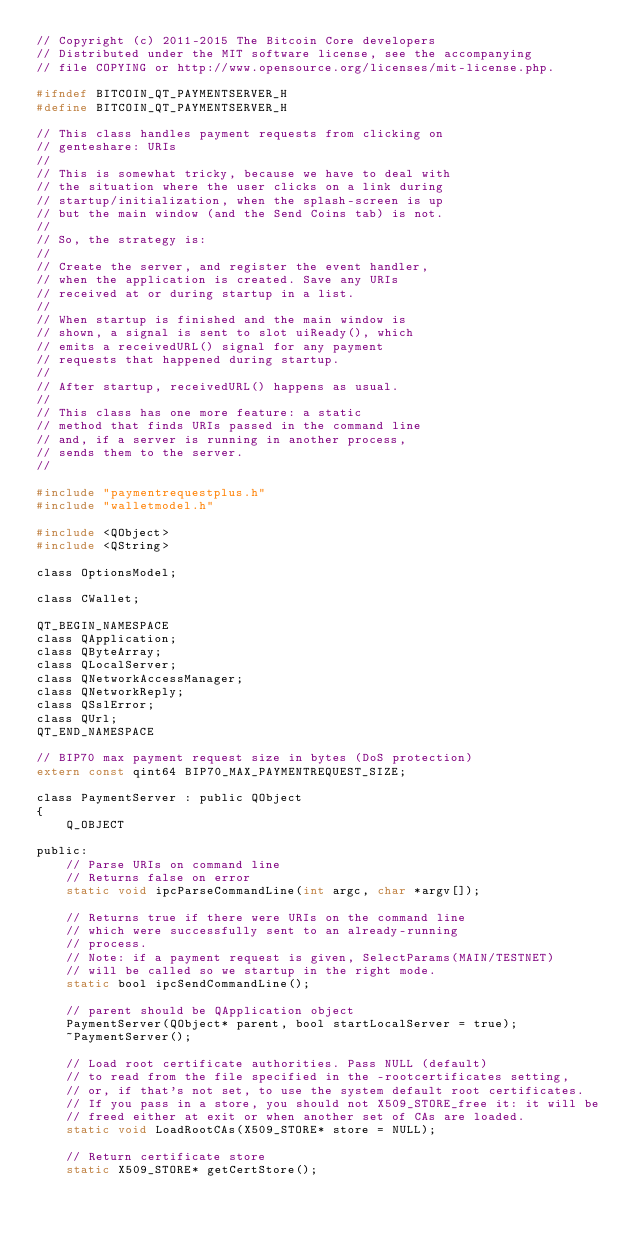Convert code to text. <code><loc_0><loc_0><loc_500><loc_500><_C_>// Copyright (c) 2011-2015 The Bitcoin Core developers
// Distributed under the MIT software license, see the accompanying
// file COPYING or http://www.opensource.org/licenses/mit-license.php.

#ifndef BITCOIN_QT_PAYMENTSERVER_H
#define BITCOIN_QT_PAYMENTSERVER_H

// This class handles payment requests from clicking on
// genteshare: URIs
//
// This is somewhat tricky, because we have to deal with
// the situation where the user clicks on a link during
// startup/initialization, when the splash-screen is up
// but the main window (and the Send Coins tab) is not.
//
// So, the strategy is:
//
// Create the server, and register the event handler,
// when the application is created. Save any URIs
// received at or during startup in a list.
//
// When startup is finished and the main window is
// shown, a signal is sent to slot uiReady(), which
// emits a receivedURL() signal for any payment
// requests that happened during startup.
//
// After startup, receivedURL() happens as usual.
//
// This class has one more feature: a static
// method that finds URIs passed in the command line
// and, if a server is running in another process,
// sends them to the server.
//

#include "paymentrequestplus.h"
#include "walletmodel.h"

#include <QObject>
#include <QString>

class OptionsModel;

class CWallet;

QT_BEGIN_NAMESPACE
class QApplication;
class QByteArray;
class QLocalServer;
class QNetworkAccessManager;
class QNetworkReply;
class QSslError;
class QUrl;
QT_END_NAMESPACE

// BIP70 max payment request size in bytes (DoS protection)
extern const qint64 BIP70_MAX_PAYMENTREQUEST_SIZE;

class PaymentServer : public QObject
{
    Q_OBJECT

public:
    // Parse URIs on command line
    // Returns false on error
    static void ipcParseCommandLine(int argc, char *argv[]);

    // Returns true if there were URIs on the command line
    // which were successfully sent to an already-running
    // process.
    // Note: if a payment request is given, SelectParams(MAIN/TESTNET)
    // will be called so we startup in the right mode.
    static bool ipcSendCommandLine();

    // parent should be QApplication object
    PaymentServer(QObject* parent, bool startLocalServer = true);
    ~PaymentServer();

    // Load root certificate authorities. Pass NULL (default)
    // to read from the file specified in the -rootcertificates setting,
    // or, if that's not set, to use the system default root certificates.
    // If you pass in a store, you should not X509_STORE_free it: it will be
    // freed either at exit or when another set of CAs are loaded.
    static void LoadRootCAs(X509_STORE* store = NULL);

    // Return certificate store
    static X509_STORE* getCertStore();
</code> 